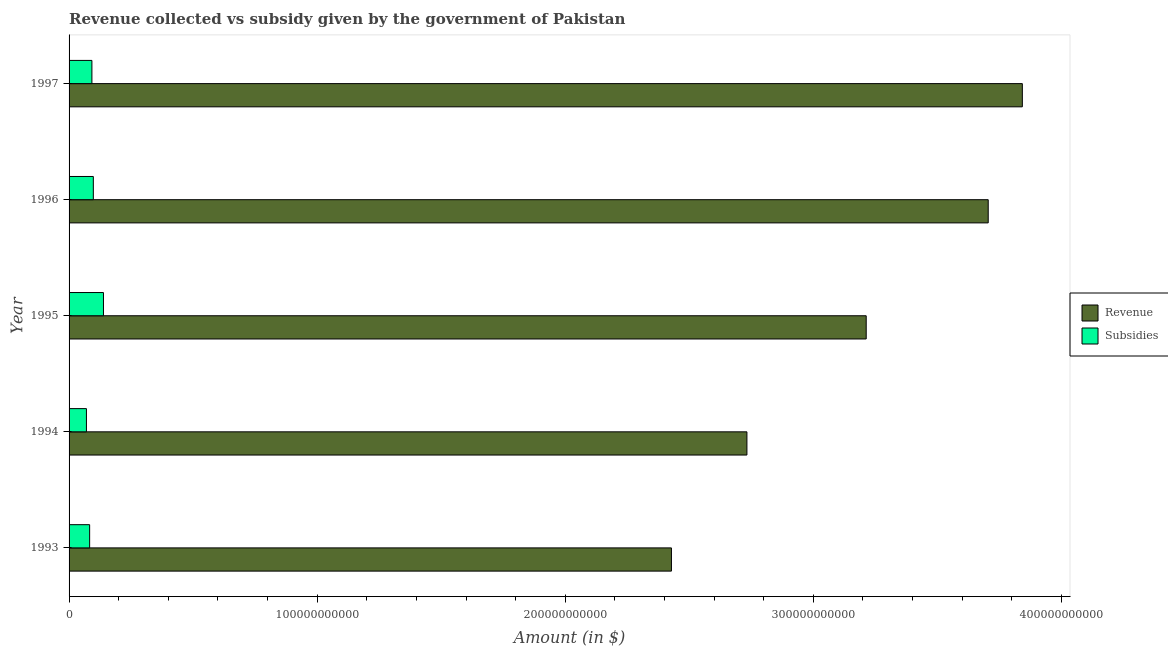How many groups of bars are there?
Offer a very short reply. 5. How many bars are there on the 1st tick from the top?
Your answer should be very brief. 2. How many bars are there on the 3rd tick from the bottom?
Your response must be concise. 2. What is the label of the 3rd group of bars from the top?
Your answer should be compact. 1995. What is the amount of subsidies given in 1996?
Ensure brevity in your answer.  9.78e+09. Across all years, what is the maximum amount of revenue collected?
Provide a succinct answer. 3.84e+11. Across all years, what is the minimum amount of subsidies given?
Provide a short and direct response. 7.00e+09. In which year was the amount of revenue collected maximum?
Give a very brief answer. 1997. What is the total amount of subsidies given in the graph?
Ensure brevity in your answer.  4.81e+1. What is the difference between the amount of revenue collected in 1994 and that in 1996?
Make the answer very short. -9.73e+1. What is the difference between the amount of subsidies given in 1995 and the amount of revenue collected in 1994?
Offer a terse response. -2.59e+11. What is the average amount of revenue collected per year?
Offer a very short reply. 3.18e+11. In the year 1995, what is the difference between the amount of revenue collected and amount of subsidies given?
Give a very brief answer. 3.07e+11. In how many years, is the amount of subsidies given greater than 280000000000 $?
Provide a short and direct response. 0. What is the ratio of the amount of subsidies given in 1995 to that in 1997?
Your answer should be very brief. 1.51. Is the difference between the amount of revenue collected in 1993 and 1997 greater than the difference between the amount of subsidies given in 1993 and 1997?
Offer a terse response. No. What is the difference between the highest and the second highest amount of subsidies given?
Give a very brief answer. 4.09e+09. What is the difference between the highest and the lowest amount of revenue collected?
Offer a terse response. 1.41e+11. What does the 1st bar from the top in 1994 represents?
Provide a short and direct response. Subsidies. What does the 2nd bar from the bottom in 1995 represents?
Your answer should be compact. Subsidies. Are all the bars in the graph horizontal?
Ensure brevity in your answer.  Yes. How many years are there in the graph?
Provide a short and direct response. 5. What is the difference between two consecutive major ticks on the X-axis?
Offer a terse response. 1.00e+11. Are the values on the major ticks of X-axis written in scientific E-notation?
Your answer should be compact. No. How are the legend labels stacked?
Keep it short and to the point. Vertical. What is the title of the graph?
Your response must be concise. Revenue collected vs subsidy given by the government of Pakistan. What is the label or title of the X-axis?
Ensure brevity in your answer.  Amount (in $). What is the label or title of the Y-axis?
Keep it short and to the point. Year. What is the Amount (in $) of Revenue in 1993?
Your response must be concise. 2.43e+11. What is the Amount (in $) in Subsidies in 1993?
Your answer should be very brief. 8.29e+09. What is the Amount (in $) in Revenue in 1994?
Provide a short and direct response. 2.73e+11. What is the Amount (in $) of Subsidies in 1994?
Your answer should be compact. 7.00e+09. What is the Amount (in $) in Revenue in 1995?
Your response must be concise. 3.21e+11. What is the Amount (in $) of Subsidies in 1995?
Your answer should be very brief. 1.39e+1. What is the Amount (in $) in Revenue in 1996?
Offer a terse response. 3.71e+11. What is the Amount (in $) in Subsidies in 1996?
Your response must be concise. 9.78e+09. What is the Amount (in $) in Revenue in 1997?
Your response must be concise. 3.84e+11. What is the Amount (in $) in Subsidies in 1997?
Provide a succinct answer. 9.21e+09. Across all years, what is the maximum Amount (in $) of Revenue?
Make the answer very short. 3.84e+11. Across all years, what is the maximum Amount (in $) in Subsidies?
Provide a short and direct response. 1.39e+1. Across all years, what is the minimum Amount (in $) of Revenue?
Your answer should be very brief. 2.43e+11. Across all years, what is the minimum Amount (in $) in Subsidies?
Offer a terse response. 7.00e+09. What is the total Amount (in $) of Revenue in the graph?
Ensure brevity in your answer.  1.59e+12. What is the total Amount (in $) of Subsidies in the graph?
Your answer should be very brief. 4.81e+1. What is the difference between the Amount (in $) in Revenue in 1993 and that in 1994?
Keep it short and to the point. -3.04e+1. What is the difference between the Amount (in $) of Subsidies in 1993 and that in 1994?
Your answer should be very brief. 1.29e+09. What is the difference between the Amount (in $) in Revenue in 1993 and that in 1995?
Provide a short and direct response. -7.85e+1. What is the difference between the Amount (in $) of Subsidies in 1993 and that in 1995?
Your answer should be very brief. -5.58e+09. What is the difference between the Amount (in $) of Revenue in 1993 and that in 1996?
Your answer should be compact. -1.28e+11. What is the difference between the Amount (in $) in Subsidies in 1993 and that in 1996?
Offer a very short reply. -1.49e+09. What is the difference between the Amount (in $) of Revenue in 1993 and that in 1997?
Provide a succinct answer. -1.41e+11. What is the difference between the Amount (in $) in Subsidies in 1993 and that in 1997?
Your answer should be compact. -9.18e+08. What is the difference between the Amount (in $) in Revenue in 1994 and that in 1995?
Ensure brevity in your answer.  -4.81e+1. What is the difference between the Amount (in $) of Subsidies in 1994 and that in 1995?
Provide a succinct answer. -6.87e+09. What is the difference between the Amount (in $) of Revenue in 1994 and that in 1996?
Your answer should be very brief. -9.73e+1. What is the difference between the Amount (in $) of Subsidies in 1994 and that in 1996?
Give a very brief answer. -2.78e+09. What is the difference between the Amount (in $) in Revenue in 1994 and that in 1997?
Give a very brief answer. -1.11e+11. What is the difference between the Amount (in $) of Subsidies in 1994 and that in 1997?
Offer a very short reply. -2.21e+09. What is the difference between the Amount (in $) of Revenue in 1995 and that in 1996?
Offer a terse response. -4.92e+1. What is the difference between the Amount (in $) in Subsidies in 1995 and that in 1996?
Your answer should be very brief. 4.09e+09. What is the difference between the Amount (in $) in Revenue in 1995 and that in 1997?
Make the answer very short. -6.29e+1. What is the difference between the Amount (in $) of Subsidies in 1995 and that in 1997?
Give a very brief answer. 4.66e+09. What is the difference between the Amount (in $) in Revenue in 1996 and that in 1997?
Make the answer very short. -1.38e+1. What is the difference between the Amount (in $) in Subsidies in 1996 and that in 1997?
Provide a succinct answer. 5.70e+08. What is the difference between the Amount (in $) in Revenue in 1993 and the Amount (in $) in Subsidies in 1994?
Keep it short and to the point. 2.36e+11. What is the difference between the Amount (in $) of Revenue in 1993 and the Amount (in $) of Subsidies in 1995?
Provide a short and direct response. 2.29e+11. What is the difference between the Amount (in $) in Revenue in 1993 and the Amount (in $) in Subsidies in 1996?
Your answer should be compact. 2.33e+11. What is the difference between the Amount (in $) of Revenue in 1993 and the Amount (in $) of Subsidies in 1997?
Provide a succinct answer. 2.34e+11. What is the difference between the Amount (in $) in Revenue in 1994 and the Amount (in $) in Subsidies in 1995?
Your answer should be very brief. 2.59e+11. What is the difference between the Amount (in $) of Revenue in 1994 and the Amount (in $) of Subsidies in 1996?
Your answer should be compact. 2.63e+11. What is the difference between the Amount (in $) in Revenue in 1994 and the Amount (in $) in Subsidies in 1997?
Provide a short and direct response. 2.64e+11. What is the difference between the Amount (in $) in Revenue in 1995 and the Amount (in $) in Subsidies in 1996?
Keep it short and to the point. 3.12e+11. What is the difference between the Amount (in $) in Revenue in 1995 and the Amount (in $) in Subsidies in 1997?
Provide a succinct answer. 3.12e+11. What is the difference between the Amount (in $) in Revenue in 1996 and the Amount (in $) in Subsidies in 1997?
Your answer should be compact. 3.61e+11. What is the average Amount (in $) in Revenue per year?
Ensure brevity in your answer.  3.18e+11. What is the average Amount (in $) of Subsidies per year?
Your response must be concise. 9.63e+09. In the year 1993, what is the difference between the Amount (in $) of Revenue and Amount (in $) of Subsidies?
Your response must be concise. 2.35e+11. In the year 1994, what is the difference between the Amount (in $) of Revenue and Amount (in $) of Subsidies?
Your answer should be compact. 2.66e+11. In the year 1995, what is the difference between the Amount (in $) in Revenue and Amount (in $) in Subsidies?
Offer a terse response. 3.07e+11. In the year 1996, what is the difference between the Amount (in $) in Revenue and Amount (in $) in Subsidies?
Your answer should be compact. 3.61e+11. In the year 1997, what is the difference between the Amount (in $) of Revenue and Amount (in $) of Subsidies?
Keep it short and to the point. 3.75e+11. What is the ratio of the Amount (in $) in Revenue in 1993 to that in 1994?
Give a very brief answer. 0.89. What is the ratio of the Amount (in $) in Subsidies in 1993 to that in 1994?
Make the answer very short. 1.18. What is the ratio of the Amount (in $) in Revenue in 1993 to that in 1995?
Give a very brief answer. 0.76. What is the ratio of the Amount (in $) of Subsidies in 1993 to that in 1995?
Provide a short and direct response. 0.6. What is the ratio of the Amount (in $) of Revenue in 1993 to that in 1996?
Offer a very short reply. 0.66. What is the ratio of the Amount (in $) in Subsidies in 1993 to that in 1996?
Provide a succinct answer. 0.85. What is the ratio of the Amount (in $) of Revenue in 1993 to that in 1997?
Make the answer very short. 0.63. What is the ratio of the Amount (in $) of Subsidies in 1993 to that in 1997?
Make the answer very short. 0.9. What is the ratio of the Amount (in $) of Revenue in 1994 to that in 1995?
Your response must be concise. 0.85. What is the ratio of the Amount (in $) of Subsidies in 1994 to that in 1995?
Provide a short and direct response. 0.5. What is the ratio of the Amount (in $) of Revenue in 1994 to that in 1996?
Your answer should be very brief. 0.74. What is the ratio of the Amount (in $) of Subsidies in 1994 to that in 1996?
Provide a short and direct response. 0.72. What is the ratio of the Amount (in $) of Revenue in 1994 to that in 1997?
Keep it short and to the point. 0.71. What is the ratio of the Amount (in $) of Subsidies in 1994 to that in 1997?
Offer a very short reply. 0.76. What is the ratio of the Amount (in $) in Revenue in 1995 to that in 1996?
Provide a succinct answer. 0.87. What is the ratio of the Amount (in $) of Subsidies in 1995 to that in 1996?
Offer a very short reply. 1.42. What is the ratio of the Amount (in $) of Revenue in 1995 to that in 1997?
Make the answer very short. 0.84. What is the ratio of the Amount (in $) of Subsidies in 1995 to that in 1997?
Your response must be concise. 1.51. What is the ratio of the Amount (in $) in Revenue in 1996 to that in 1997?
Give a very brief answer. 0.96. What is the ratio of the Amount (in $) of Subsidies in 1996 to that in 1997?
Your answer should be very brief. 1.06. What is the difference between the highest and the second highest Amount (in $) of Revenue?
Ensure brevity in your answer.  1.38e+1. What is the difference between the highest and the second highest Amount (in $) in Subsidies?
Your answer should be compact. 4.09e+09. What is the difference between the highest and the lowest Amount (in $) of Revenue?
Your response must be concise. 1.41e+11. What is the difference between the highest and the lowest Amount (in $) of Subsidies?
Provide a succinct answer. 6.87e+09. 